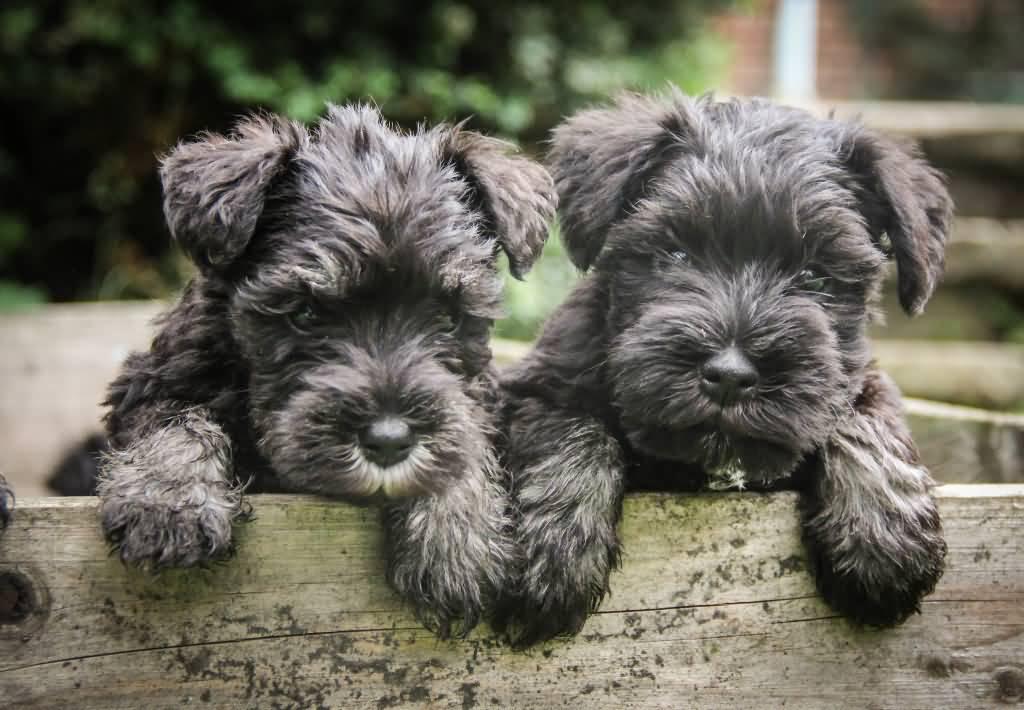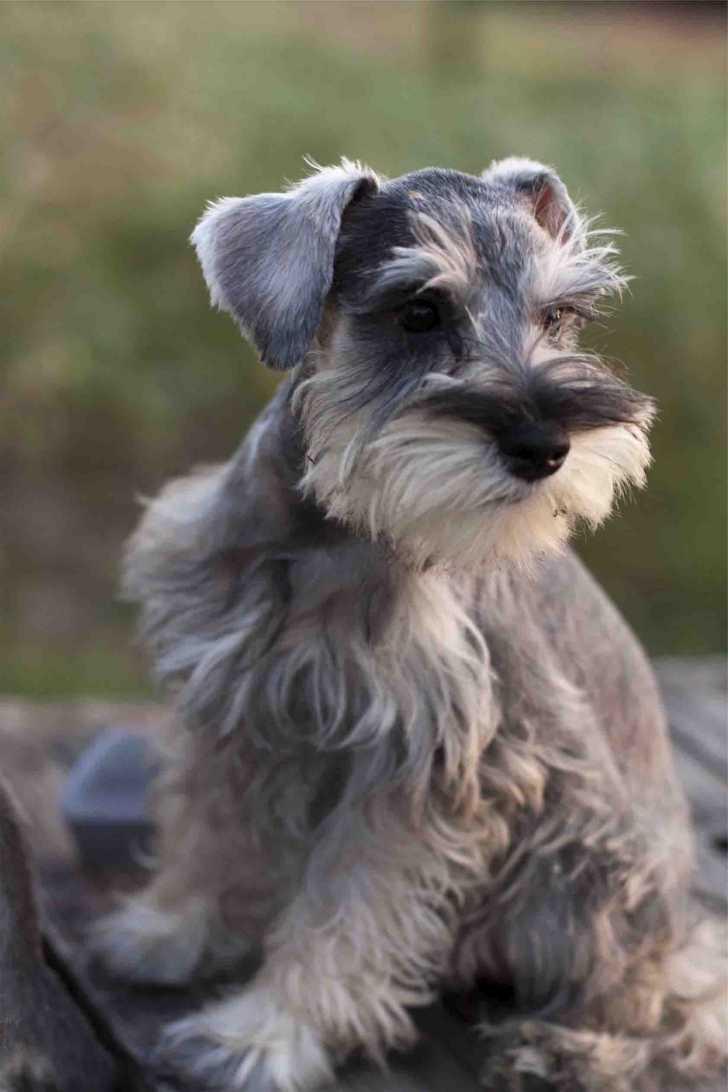The first image is the image on the left, the second image is the image on the right. For the images displayed, is the sentence "There is a single dog sitting in the grass in one of the images." factually correct? Answer yes or no. No. The first image is the image on the left, the second image is the image on the right. Evaluate the accuracy of this statement regarding the images: "An image shows one forward facing dog wearing a red collar.". Is it true? Answer yes or no. No. 